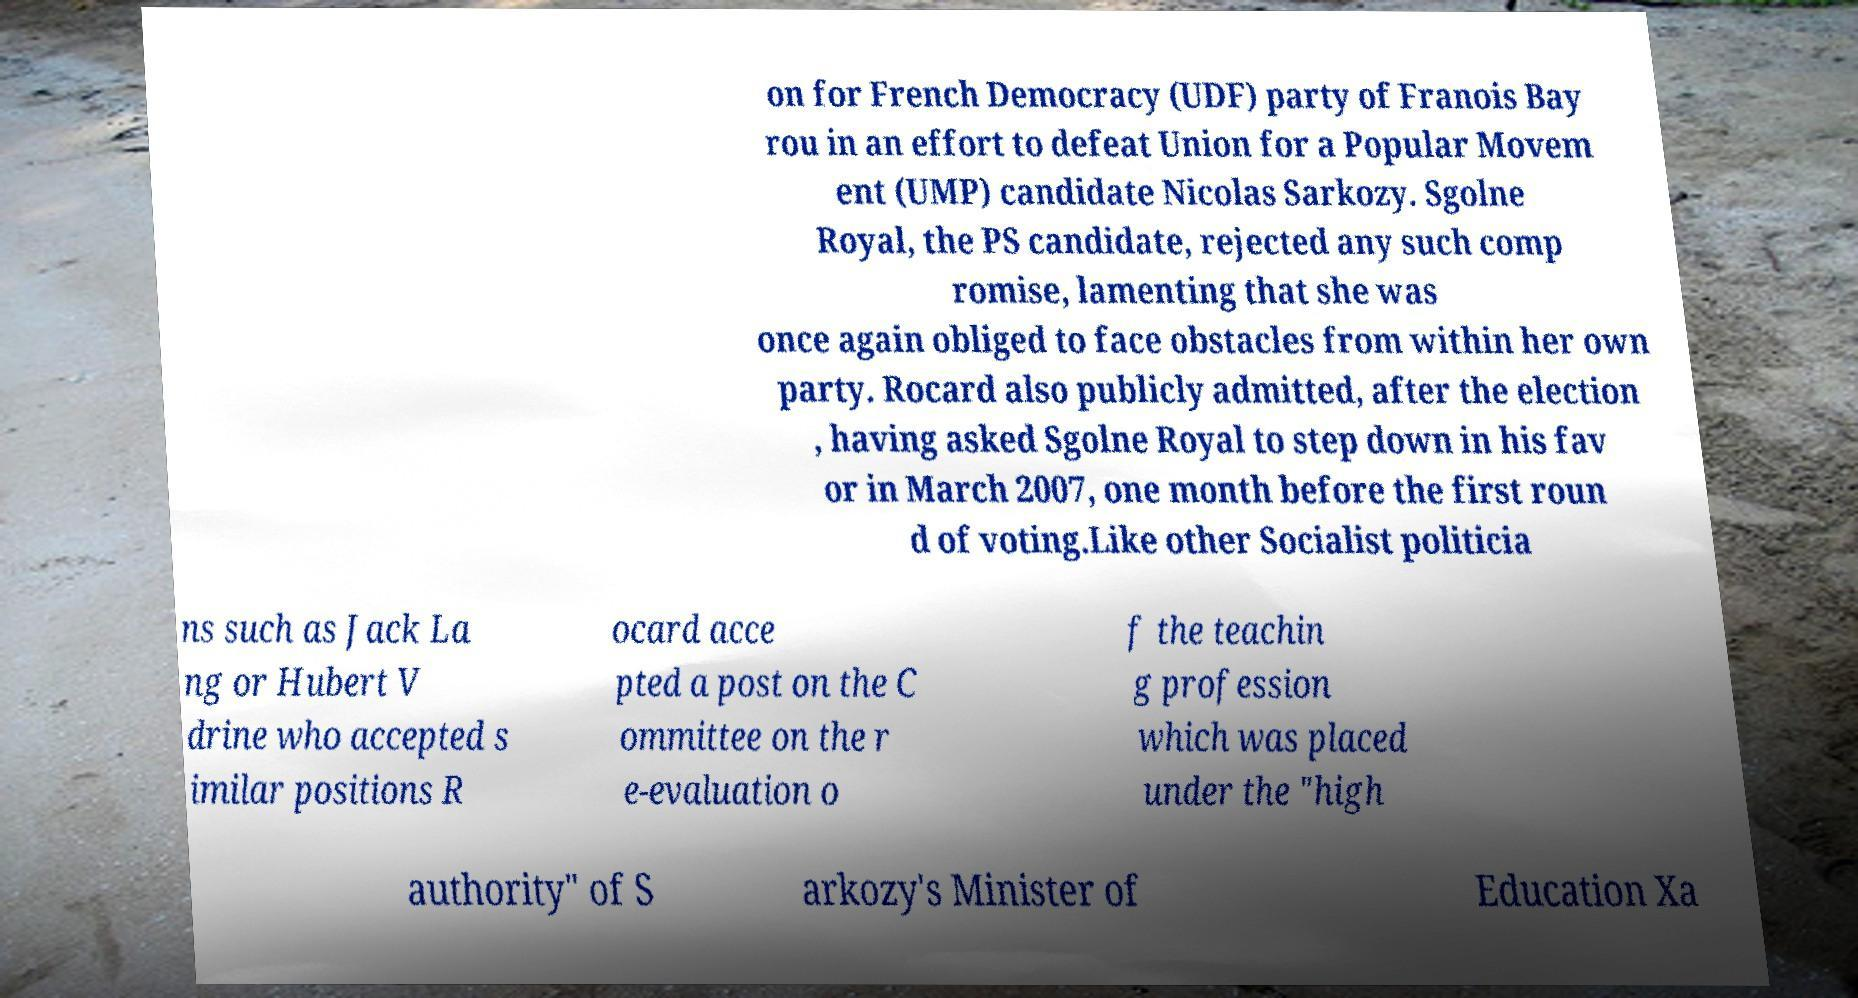Please read and relay the text visible in this image. What does it say? on for French Democracy (UDF) party of Franois Bay rou in an effort to defeat Union for a Popular Movem ent (UMP) candidate Nicolas Sarkozy. Sgolne Royal, the PS candidate, rejected any such comp romise, lamenting that she was once again obliged to face obstacles from within her own party. Rocard also publicly admitted, after the election , having asked Sgolne Royal to step down in his fav or in March 2007, one month before the first roun d of voting.Like other Socialist politicia ns such as Jack La ng or Hubert V drine who accepted s imilar positions R ocard acce pted a post on the C ommittee on the r e-evaluation o f the teachin g profession which was placed under the "high authority" of S arkozy's Minister of Education Xa 